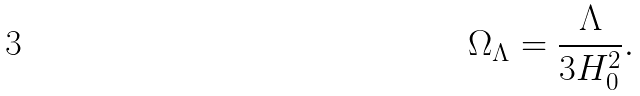<formula> <loc_0><loc_0><loc_500><loc_500>\Omega _ { \Lambda } = { \frac { \Lambda } { 3 H _ { 0 } ^ { 2 } } } .</formula> 